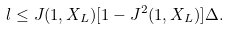Convert formula to latex. <formula><loc_0><loc_0><loc_500><loc_500>l \leq J ( 1 , X _ { L } ) [ 1 - J ^ { 2 } ( 1 , X _ { L } ) ] \Delta .</formula> 